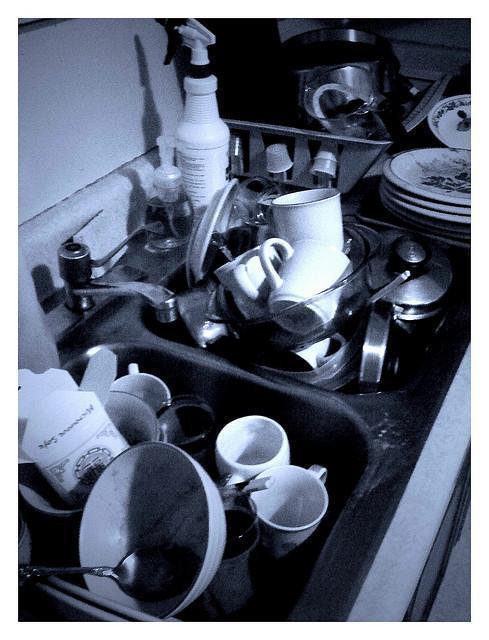How many bottles are in the picture?
Give a very brief answer. 3. How many cups are there?
Give a very brief answer. 7. How many bowls are visible?
Give a very brief answer. 3. How many sinks are in the picture?
Give a very brief answer. 2. How many people can fit on the couch?
Give a very brief answer. 0. 